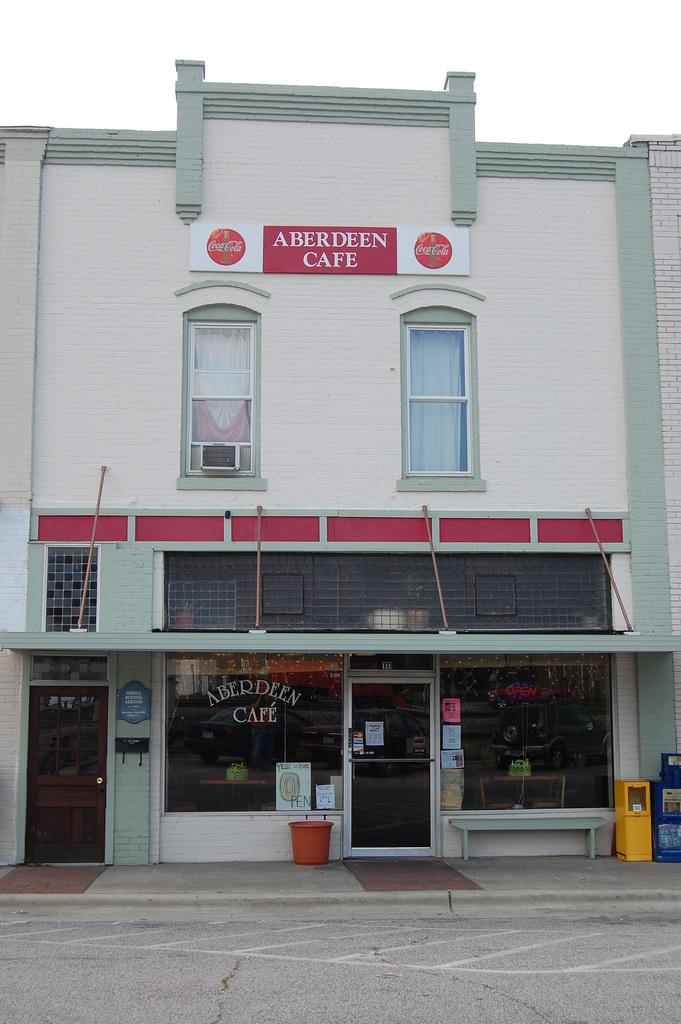What type of structure is present in the image? There is a building in the image. What is located near the building? There is a board in the image. What features can be seen on the building? The building has windows and doors. What other objects are visible in the image? There is a bin, posters, and glasses in the image. What is the setting of the image? There is a road in the image, and the sky is visible in the background. How many pizzas are being served on the glasses in the image? There are no pizzas present in the image; the glasses are not serving any food. Can you see any jellyfish swimming in the sky in the image? There are no jellyfish visible in the image; the sky is clear and does not contain any marine life. 